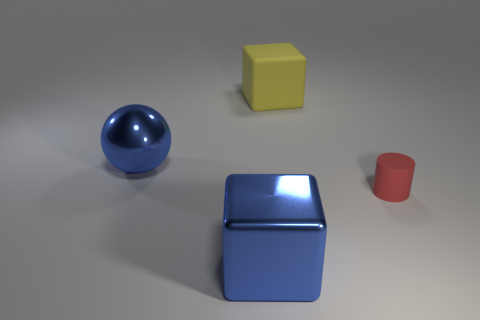Subtract 0 blue cylinders. How many objects are left? 4 Subtract all cylinders. How many objects are left? 3 Subtract 1 blocks. How many blocks are left? 1 Subtract all red blocks. Subtract all blue balls. How many blocks are left? 2 Subtract all yellow cylinders. How many blue cubes are left? 1 Subtract all big rubber objects. Subtract all small matte objects. How many objects are left? 2 Add 4 big cubes. How many big cubes are left? 6 Add 4 blue metal cubes. How many blue metal cubes exist? 5 Add 4 blue metal things. How many objects exist? 8 Subtract all yellow cubes. How many cubes are left? 1 